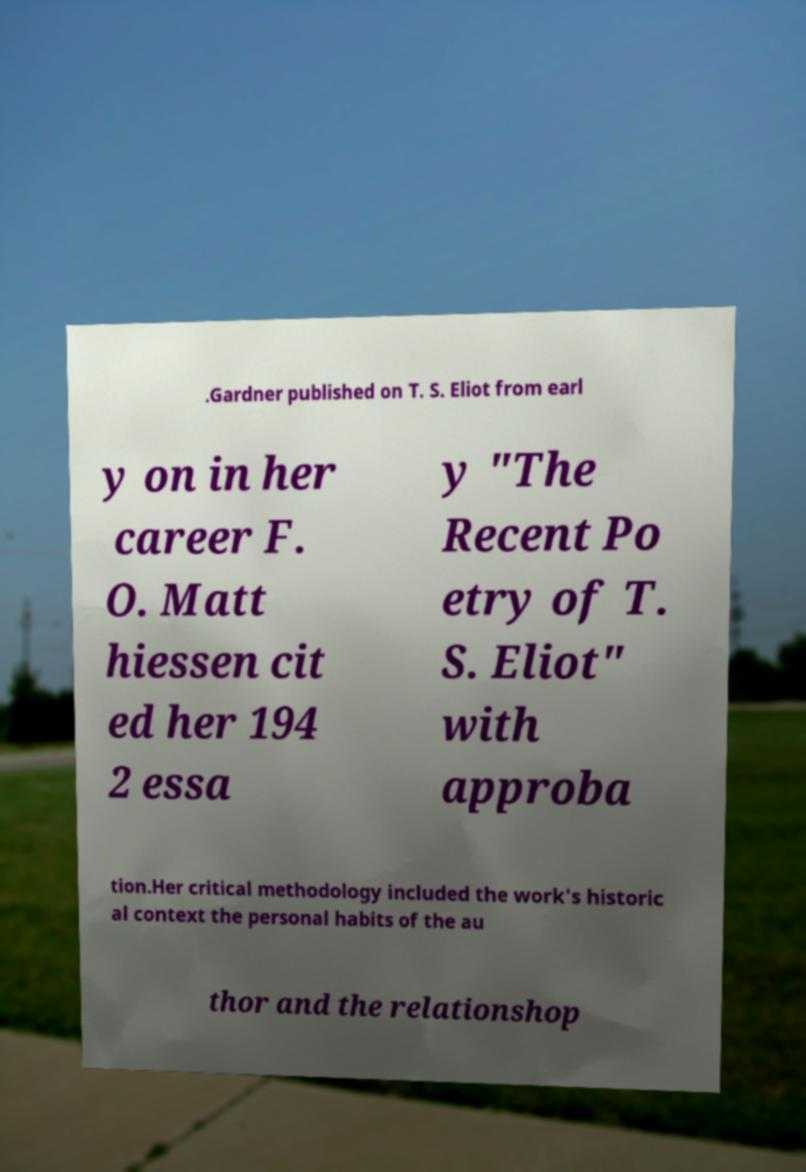Could you extract and type out the text from this image? .Gardner published on T. S. Eliot from earl y on in her career F. O. Matt hiessen cit ed her 194 2 essa y "The Recent Po etry of T. S. Eliot" with approba tion.Her critical methodology included the work's historic al context the personal habits of the au thor and the relationshop 